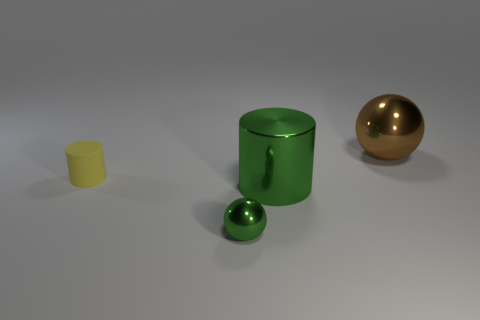There is a tiny green thing; is its shape the same as the large object behind the matte thing?
Your answer should be compact. Yes. Are there any tiny matte things that have the same color as the large sphere?
Your response must be concise. No. How many blocks are small yellow objects or small green objects?
Provide a short and direct response. 0. Are there any other cyan matte things of the same shape as the rubber thing?
Make the answer very short. No. How many other objects are the same color as the metallic cylinder?
Keep it short and to the point. 1. Is the number of yellow cylinders that are behind the brown metallic ball less than the number of big green shiny cylinders?
Ensure brevity in your answer.  Yes. How many tiny cylinders are there?
Ensure brevity in your answer.  1. How many small cylinders have the same material as the small green thing?
Provide a succinct answer. 0. What number of objects are objects behind the small cylinder or big blue rubber spheres?
Offer a terse response. 1. Is the number of tiny green spheres right of the small cylinder less than the number of cylinders that are to the left of the large brown thing?
Make the answer very short. Yes. 